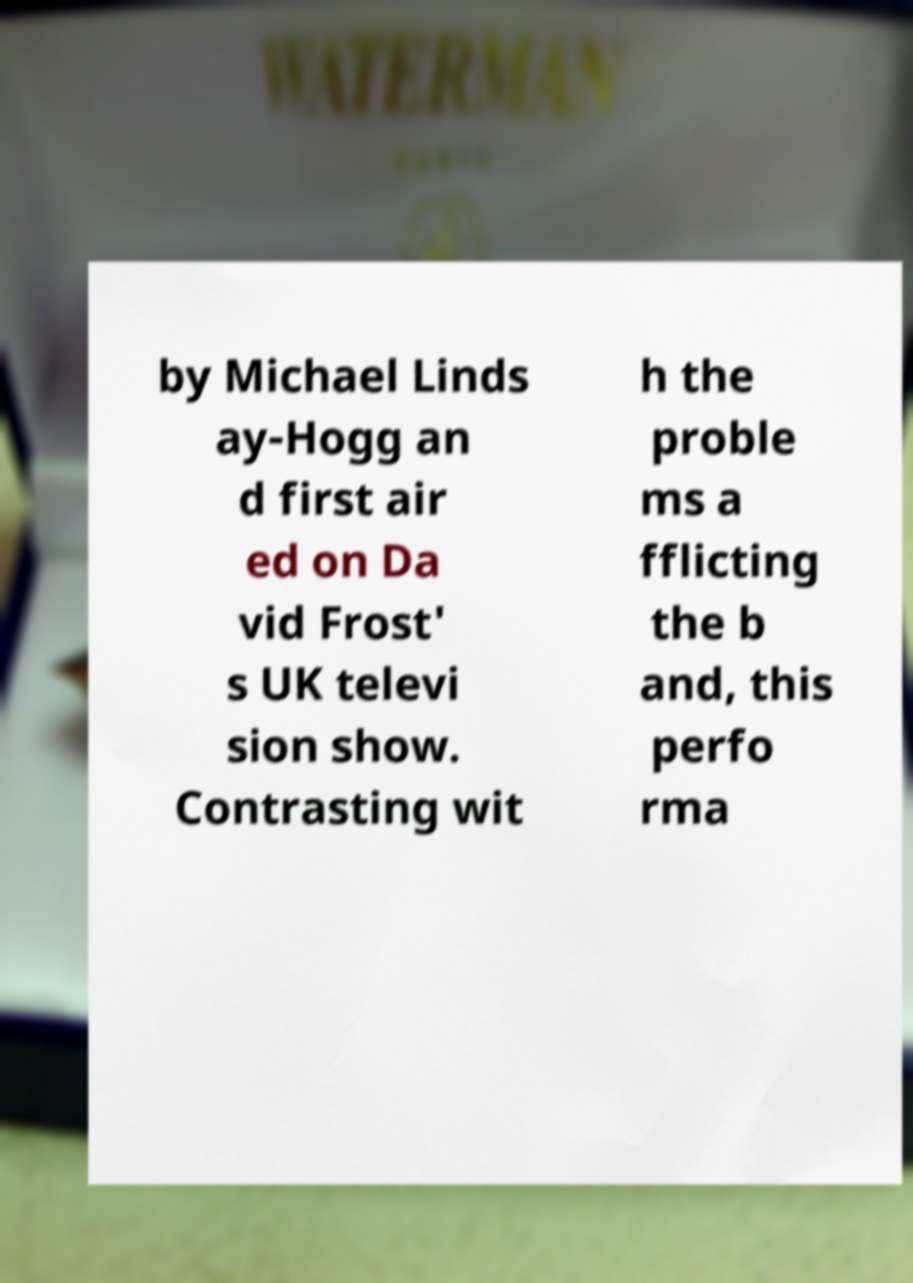What messages or text are displayed in this image? I need them in a readable, typed format. by Michael Linds ay-Hogg an d first air ed on Da vid Frost' s UK televi sion show. Contrasting wit h the proble ms a fflicting the b and, this perfo rma 